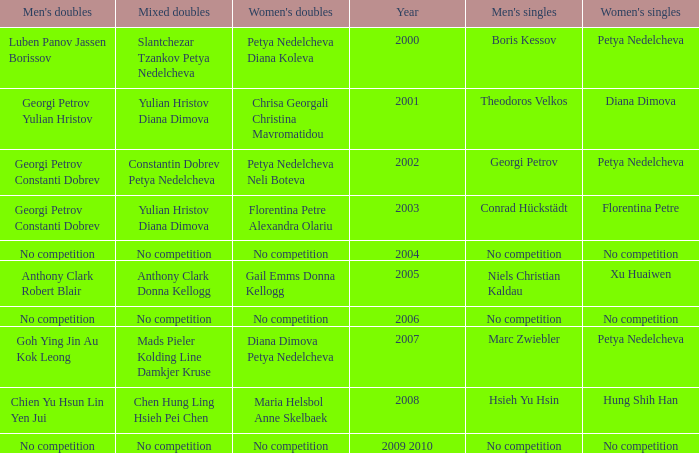In what year was there no competition for women? 2004, 2006, 2009 2010. 